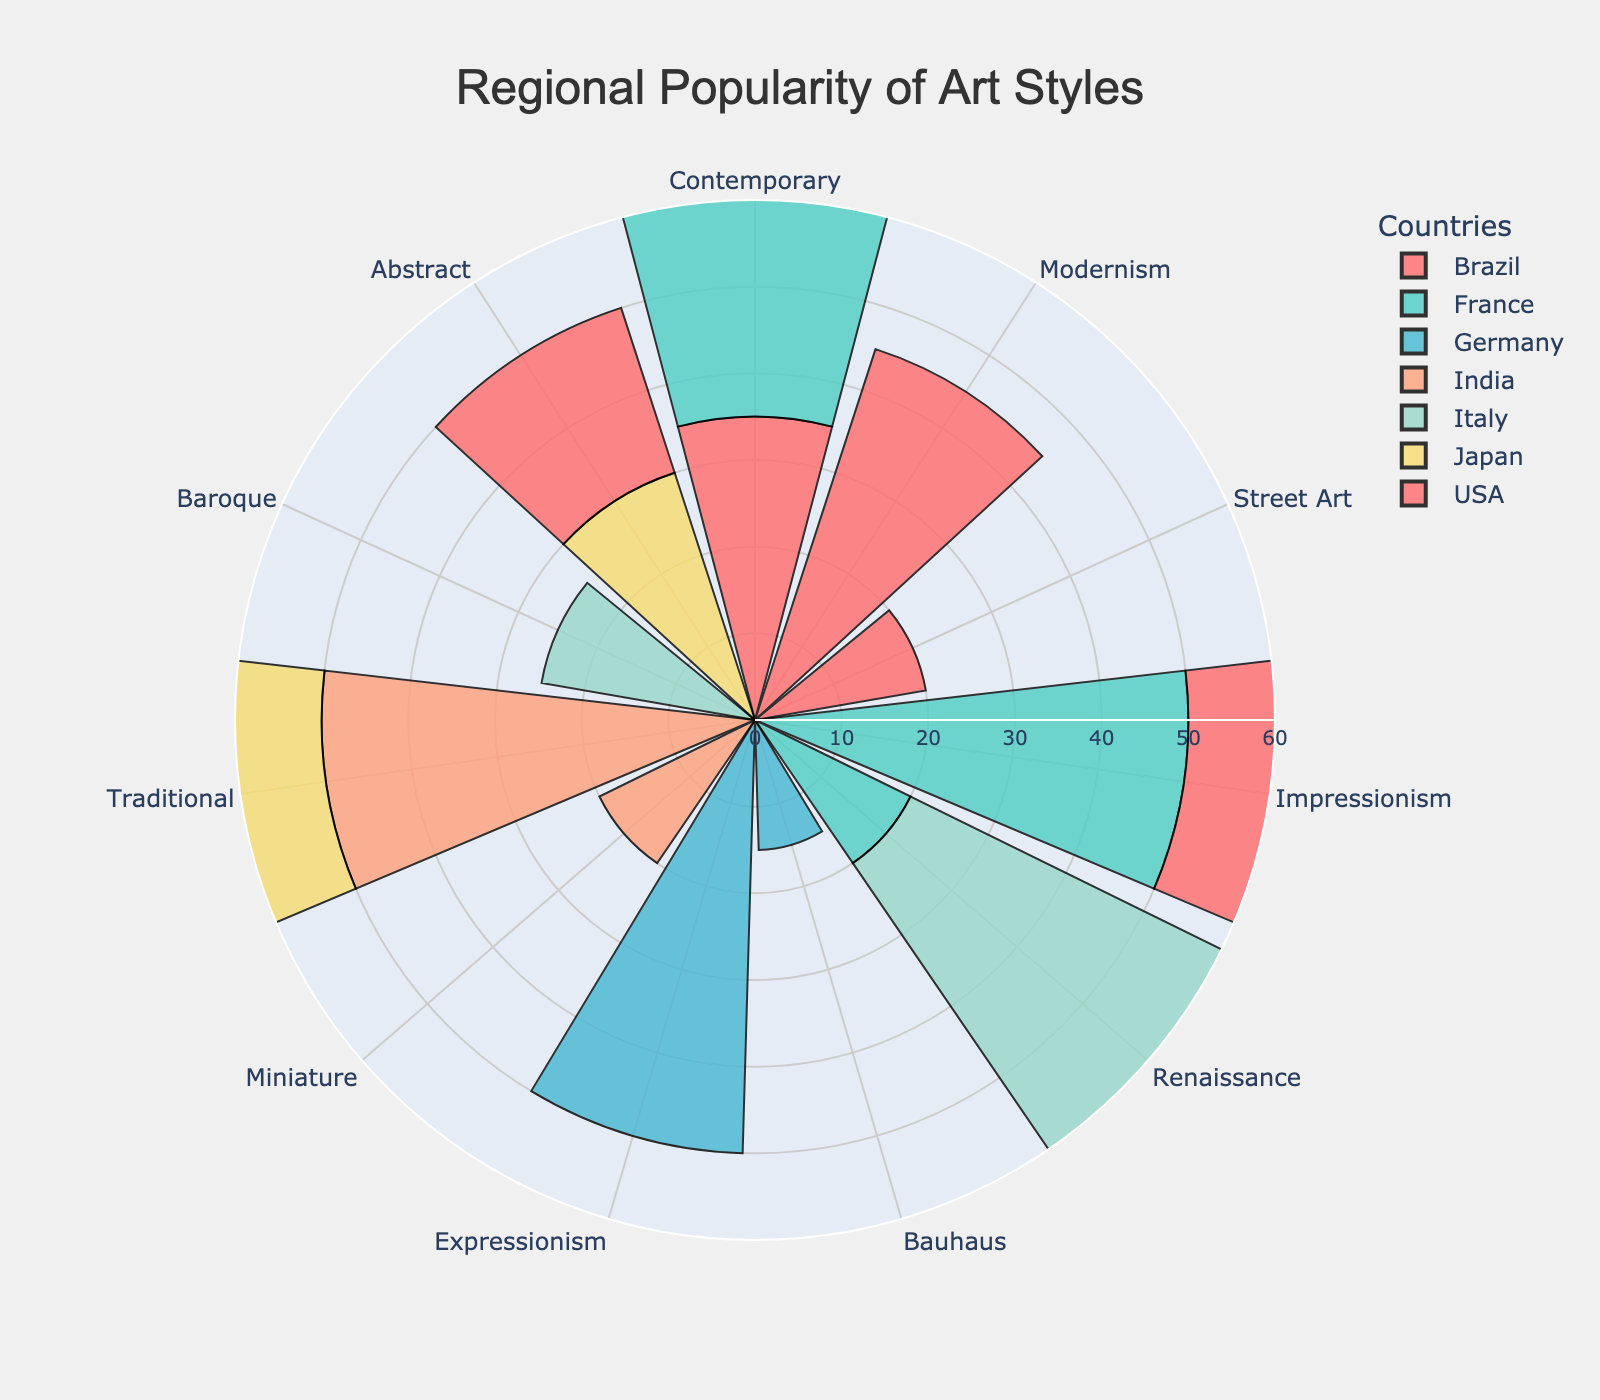What is the most popular art style in the USA? The USA has three different art styles represented: Impressionism with 35, Contemporary with 45, and Abstract with 20. The most popular art style is the one with the highest popularity value, which is Contemporary with 45.
Answer: Contemporary Which country has the highest popularity for Impressionism? Impressionism is present in the USA and France. The popularity values are 35 for the USA and 50 for France. France has the higher value for Impressionism.
Answer: France What is the combined popularity of Renaissance art styles in France and Italy? Renaissance has a popularity of 20 in France and 55 in Italy. Summing these values gives us 20 + 55 = 75.
Answer: 75 Compare the popularity of Contemporary art styles in Japan and Germany. Which country shows a higher value? Japan has a popularity of 40 for Contemporary, while Germany has 35. Japan has the higher value.
Answer: Japan Which art style is equally popular in two different countries? Abstract art is equally popular in the USA and Japan, both with a value of 30.
Answer: Abstract How many countries show a preference for Contemporary art over other styles? To determine this, we look for countries where Contemporary has the highest popularity among all listed styles. USA (45), Japan (40), Brazil (35), India (30), and Germany (35) all have Contemporary as the most popular style. This applies to 5 countries.
Answer: 5 What is the least popular art style in Italy? Italy has three art styles represented: Renaissance (55), Baroque (25), and Contemporary (20). Contemporary with 20 is the least popular.
Answer: Contemporary Which country has the highest combined popularity for Traditional and Contemporary art styles? The only countries with both Traditional and Contemporary are Japan and India. Japan has 30 (Traditional) + 40 (Contemporary) = 70 and India has 50 (Traditional) + 30 (Contemporary) = 80. India has the highest combined popularity.
Answer: India What is the range of popularity values for art styles in Germany? In Germany, the popularity values are Expressionism (50), Contemporary (35), and Bauhaus (15). The range is calculated as the difference between the highest and lowest values: 50 - 15 = 35.
Answer: 35 What art styles are most popular in three different countries? USA (Contemporary, 45), France (Impressionism, 50), and Italy (Renaissance, 55) have the most popular art styles with their respective highest values.
Answer: USA: Contemporary, France: Impressionism, Italy: Renaissance 